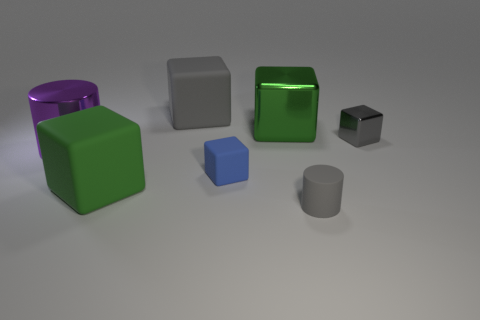Subtract 1 cylinders. How many cylinders are left? 1 Add 2 green rubber objects. How many objects exist? 9 Subtract all large green cubes. How many cubes are left? 3 Subtract all cylinders. How many objects are left? 5 Add 7 large blue shiny cylinders. How many large blue shiny cylinders exist? 7 Subtract all gray cylinders. How many cylinders are left? 1 Subtract 0 blue cylinders. How many objects are left? 7 Subtract all purple cylinders. Subtract all blue spheres. How many cylinders are left? 1 Subtract all cyan cubes. How many yellow cylinders are left? 0 Subtract all metallic things. Subtract all tiny red metallic spheres. How many objects are left? 4 